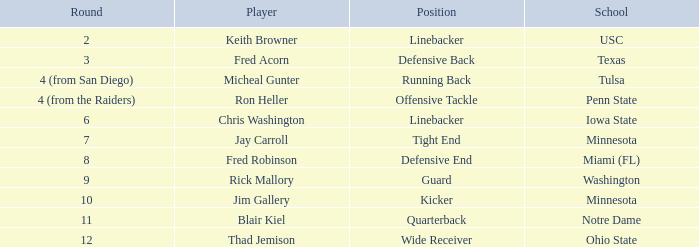What is the selection number for penn state? 112.0. 